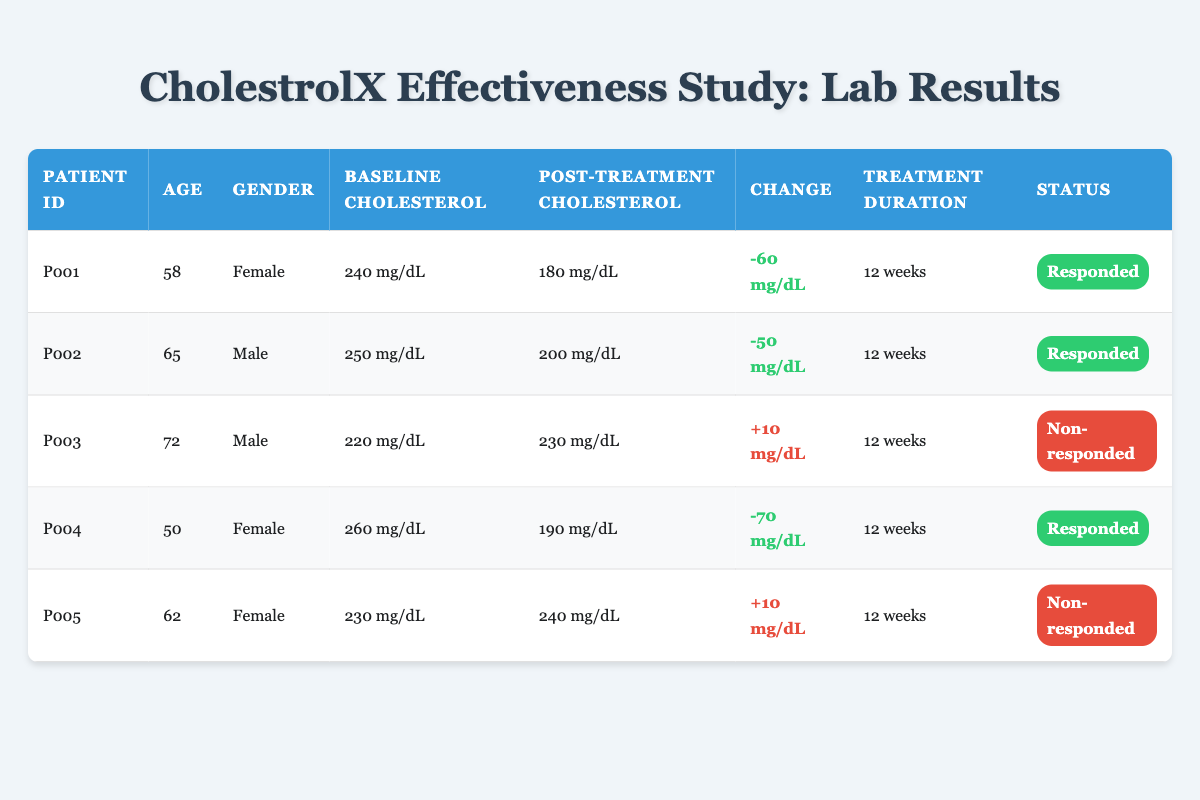What is the baseline cholesterol level of patient P001? The table indicates the baseline cholesterol level for patient P001 under the "Baseline Cholesterol" column, which shows a value of 240 mg/dL.
Answer: 240 mg/dL How many patients responded to the treatment? By reviewing the "Status" column, three patients are labeled as "Responded" (P001, P002, and P004).
Answer: 3 What is the total reduction in cholesterol levels for all patients who responded? The reductions for responders are as follows: P001 (-60 mg/dL), P002 (-50 mg/dL), and P004 (-70 mg/dL). Summing these changes gives -60 + (-50) + (-70) = -180 mg/dL.
Answer: -180 mg/dL Did any patient experience an increase in cholesterol levels after treatment? By examining the "Change" column, patients P003 and P005 both have positive changes (+10 mg/dL), indicating an increase in cholesterol levels after treatment.
Answer: Yes What is the average age of the patients who did not respond to the treatment? The ages of non-responding patients are P003 (72 years) and P005 (62 years). To find the average: (72 + 62) / 2 = 67 years.
Answer: 67 years Which patient had the highest baseline cholesterol level? Among all baseline cholesterol levels, patient P004 has the highest value of 260 mg/dL.
Answer: P004 What is the percentage of male patients in this study? There are 5 total patients, with 2 being male (P002 and P003). To find the percentage, (2/5) * 100 = 40%.
Answer: 40% What is the overall trend in cholesterol levels for patients taking CholestrolX? Out of the total 5 patients, 3 responded with decreases and 2 did not respond with increases. Thus, the overall trend indicates a positive effect of the drug on cholesterol levels for most patients.
Answer: Positive trend Was the treatment duration the same for all patients? The "Treatment Duration" column for all patients indicates a consistent duration of 12 weeks for each patient.
Answer: Yes 